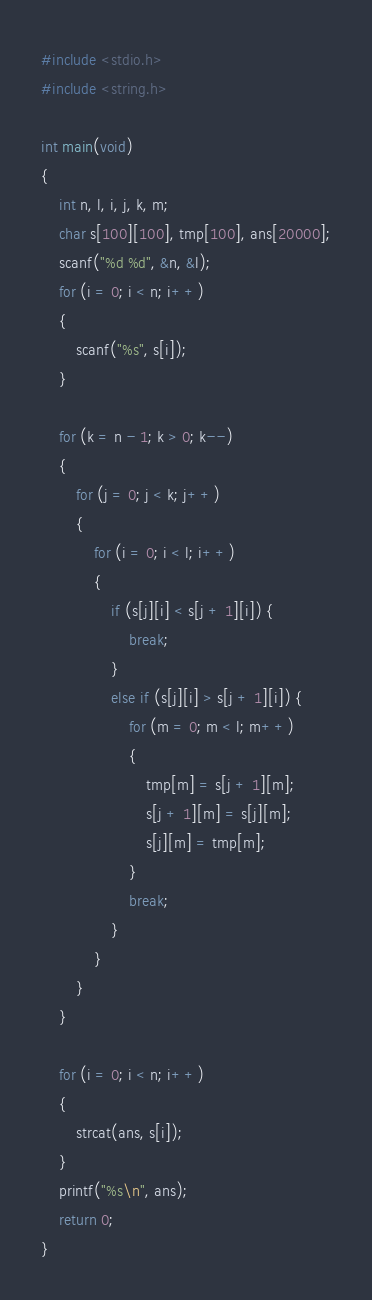<code> <loc_0><loc_0><loc_500><loc_500><_C_>#include <stdio.h>
#include <string.h>

int main(void)
{
    int n, l, i, j, k, m;
    char s[100][100], tmp[100], ans[20000];
    scanf("%d %d", &n, &l);
    for (i = 0; i < n; i++)
    {
        scanf("%s", s[i]);
    }

    for (k = n - 1; k > 0; k--)
    {
        for (j = 0; j < k; j++)
        {
            for (i = 0; i < l; i++)
            {
                if (s[j][i] < s[j + 1][i]) {
                    break;
                }
                else if (s[j][i] > s[j + 1][i]) {
                    for (m = 0; m < l; m++)
                    {
                        tmp[m] = s[j + 1][m];
                        s[j + 1][m] = s[j][m];
                        s[j][m] = tmp[m];
                    }
                    break;
                }
            }
        }
    }

    for (i = 0; i < n; i++)
    {
        strcat(ans, s[i]);
    }
    printf("%s\n", ans);
    return 0;
}
</code> 